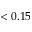<formula> <loc_0><loc_0><loc_500><loc_500>< 0 . 1 5</formula> 